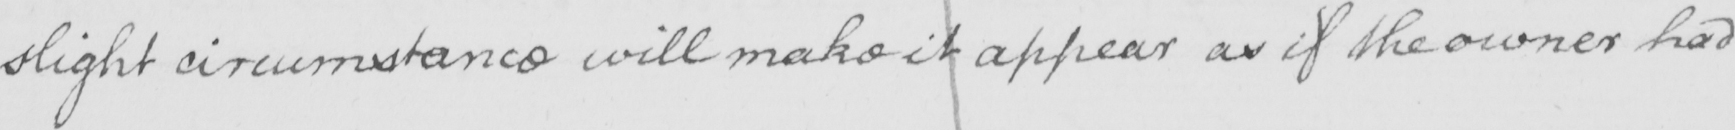What does this handwritten line say? slight circumstance will make it appear as if the owner had 